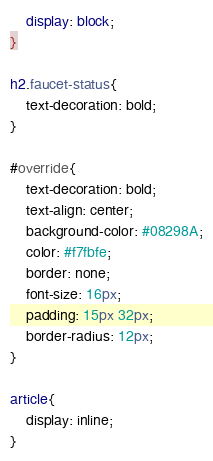Convert code to text. <code><loc_0><loc_0><loc_500><loc_500><_CSS_>	display: block;
}

h2.faucet-status{
	text-decoration: bold;
}

#override{
	text-decoration: bold;
	text-align: center; 
	background-color: #08298A;
	color: #f7fbfe;
	border: none;
	font-size: 16px;
	padding: 15px 32px;
	border-radius: 12px;
}

article{
	display: inline;
}

</code> 